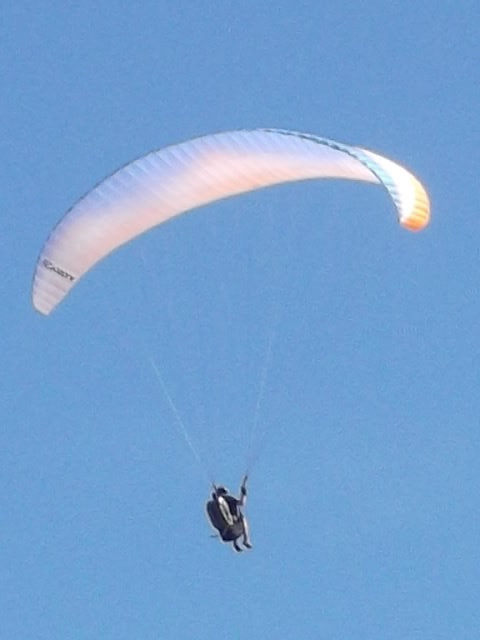Describe the objects in this image and their specific colors. I can see kite in gray, lavender, darkgray, and lightgray tones and people in gray, darkgray, and black tones in this image. 